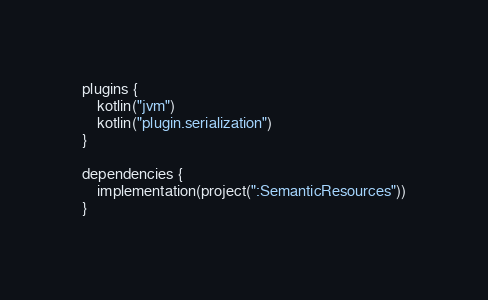Convert code to text. <code><loc_0><loc_0><loc_500><loc_500><_Kotlin_>plugins {
    kotlin("jvm")
    kotlin("plugin.serialization")
}

dependencies {
    implementation(project(":SemanticResources"))
}
</code> 